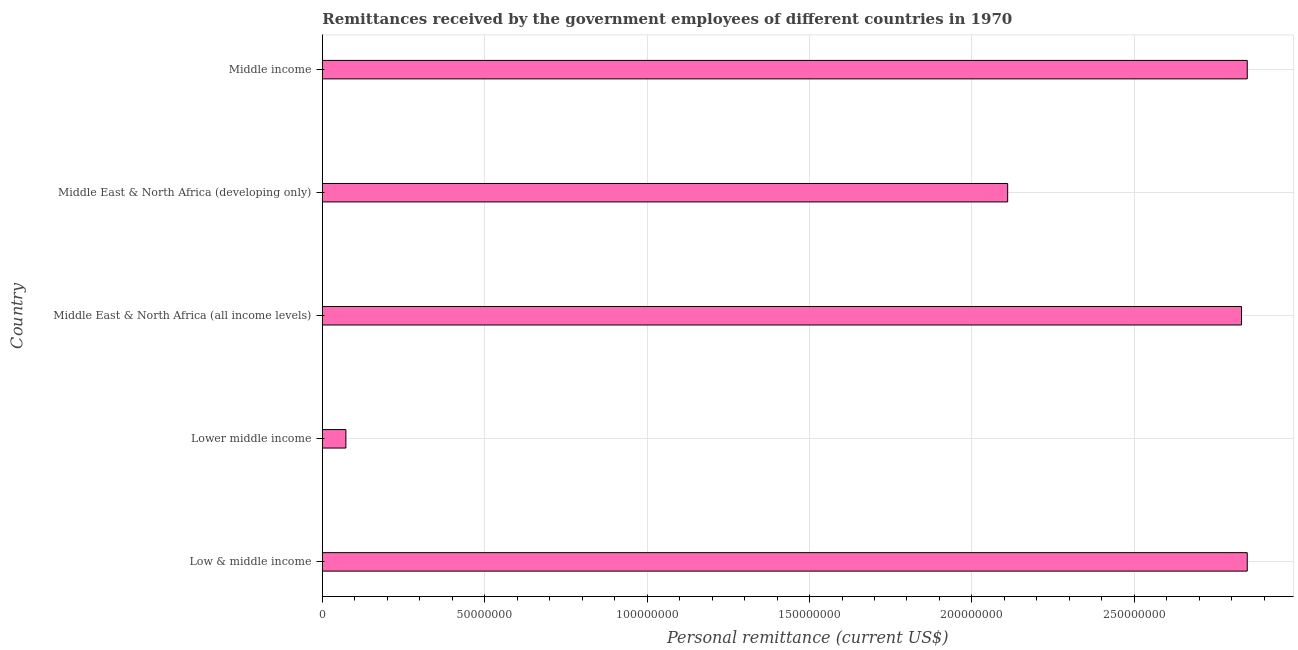Does the graph contain grids?
Make the answer very short. Yes. What is the title of the graph?
Your response must be concise. Remittances received by the government employees of different countries in 1970. What is the label or title of the X-axis?
Your response must be concise. Personal remittance (current US$). What is the label or title of the Y-axis?
Your answer should be compact. Country. What is the personal remittances in Middle East & North Africa (developing only)?
Keep it short and to the point. 2.11e+08. Across all countries, what is the maximum personal remittances?
Your answer should be very brief. 2.85e+08. Across all countries, what is the minimum personal remittances?
Your answer should be very brief. 7.26e+06. In which country was the personal remittances maximum?
Keep it short and to the point. Low & middle income. In which country was the personal remittances minimum?
Offer a terse response. Lower middle income. What is the sum of the personal remittances?
Keep it short and to the point. 1.07e+09. What is the difference between the personal remittances in Middle East & North Africa (all income levels) and Middle income?
Your answer should be very brief. -1.76e+06. What is the average personal remittances per country?
Make the answer very short. 2.14e+08. What is the median personal remittances?
Your answer should be compact. 2.83e+08. Is the personal remittances in Low & middle income less than that in Lower middle income?
Your answer should be very brief. No. What is the difference between the highest and the second highest personal remittances?
Your response must be concise. 0. What is the difference between the highest and the lowest personal remittances?
Make the answer very short. 2.77e+08. How many bars are there?
Provide a short and direct response. 5. Are all the bars in the graph horizontal?
Your response must be concise. Yes. Are the values on the major ticks of X-axis written in scientific E-notation?
Offer a terse response. No. What is the Personal remittance (current US$) in Low & middle income?
Your answer should be compact. 2.85e+08. What is the Personal remittance (current US$) in Lower middle income?
Make the answer very short. 7.26e+06. What is the Personal remittance (current US$) in Middle East & North Africa (all income levels)?
Ensure brevity in your answer.  2.83e+08. What is the Personal remittance (current US$) in Middle East & North Africa (developing only)?
Give a very brief answer. 2.11e+08. What is the Personal remittance (current US$) of Middle income?
Offer a terse response. 2.85e+08. What is the difference between the Personal remittance (current US$) in Low & middle income and Lower middle income?
Your response must be concise. 2.77e+08. What is the difference between the Personal remittance (current US$) in Low & middle income and Middle East & North Africa (all income levels)?
Keep it short and to the point. 1.76e+06. What is the difference between the Personal remittance (current US$) in Low & middle income and Middle East & North Africa (developing only)?
Your response must be concise. 7.38e+07. What is the difference between the Personal remittance (current US$) in Low & middle income and Middle income?
Your response must be concise. 0. What is the difference between the Personal remittance (current US$) in Lower middle income and Middle East & North Africa (all income levels)?
Make the answer very short. -2.76e+08. What is the difference between the Personal remittance (current US$) in Lower middle income and Middle East & North Africa (developing only)?
Make the answer very short. -2.04e+08. What is the difference between the Personal remittance (current US$) in Lower middle income and Middle income?
Your answer should be very brief. -2.77e+08. What is the difference between the Personal remittance (current US$) in Middle East & North Africa (all income levels) and Middle East & North Africa (developing only)?
Your response must be concise. 7.20e+07. What is the difference between the Personal remittance (current US$) in Middle East & North Africa (all income levels) and Middle income?
Your answer should be very brief. -1.76e+06. What is the difference between the Personal remittance (current US$) in Middle East & North Africa (developing only) and Middle income?
Provide a short and direct response. -7.38e+07. What is the ratio of the Personal remittance (current US$) in Low & middle income to that in Lower middle income?
Give a very brief answer. 39.22. What is the ratio of the Personal remittance (current US$) in Low & middle income to that in Middle East & North Africa (all income levels)?
Provide a succinct answer. 1.01. What is the ratio of the Personal remittance (current US$) in Low & middle income to that in Middle East & North Africa (developing only)?
Provide a succinct answer. 1.35. What is the ratio of the Personal remittance (current US$) in Low & middle income to that in Middle income?
Give a very brief answer. 1. What is the ratio of the Personal remittance (current US$) in Lower middle income to that in Middle East & North Africa (all income levels)?
Offer a very short reply. 0.03. What is the ratio of the Personal remittance (current US$) in Lower middle income to that in Middle East & North Africa (developing only)?
Offer a terse response. 0.03. What is the ratio of the Personal remittance (current US$) in Lower middle income to that in Middle income?
Make the answer very short. 0.03. What is the ratio of the Personal remittance (current US$) in Middle East & North Africa (all income levels) to that in Middle East & North Africa (developing only)?
Offer a terse response. 1.34. What is the ratio of the Personal remittance (current US$) in Middle East & North Africa (all income levels) to that in Middle income?
Give a very brief answer. 0.99. What is the ratio of the Personal remittance (current US$) in Middle East & North Africa (developing only) to that in Middle income?
Your answer should be very brief. 0.74. 